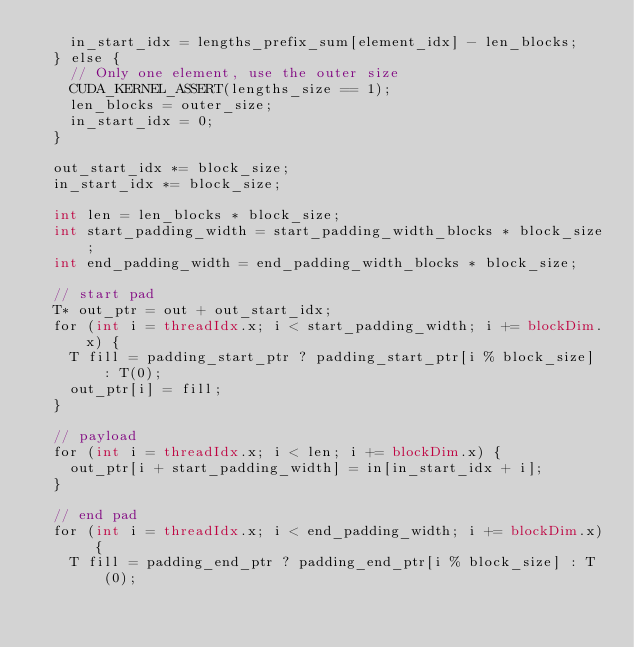<code> <loc_0><loc_0><loc_500><loc_500><_Cuda_>    in_start_idx = lengths_prefix_sum[element_idx] - len_blocks;
  } else {
    // Only one element, use the outer size
    CUDA_KERNEL_ASSERT(lengths_size == 1);
    len_blocks = outer_size;
    in_start_idx = 0;
  }

  out_start_idx *= block_size;
  in_start_idx *= block_size;

  int len = len_blocks * block_size;
  int start_padding_width = start_padding_width_blocks * block_size;
  int end_padding_width = end_padding_width_blocks * block_size;

  // start pad
  T* out_ptr = out + out_start_idx;
  for (int i = threadIdx.x; i < start_padding_width; i += blockDim.x) {
    T fill = padding_start_ptr ? padding_start_ptr[i % block_size] : T(0);
    out_ptr[i] = fill;
  }

  // payload
  for (int i = threadIdx.x; i < len; i += blockDim.x) {
    out_ptr[i + start_padding_width] = in[in_start_idx + i];
  }

  // end pad
  for (int i = threadIdx.x; i < end_padding_width; i += blockDim.x) {
    T fill = padding_end_ptr ? padding_end_ptr[i % block_size] : T(0);</code> 